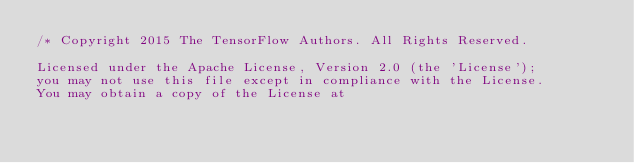Convert code to text. <code><loc_0><loc_0><loc_500><loc_500><_JavaScript_>/* Copyright 2015 The TensorFlow Authors. All Rights Reserved.

Licensed under the Apache License, Version 2.0 (the 'License');
you may not use this file except in compliance with the License.
You may obtain a copy of the License at
</code> 